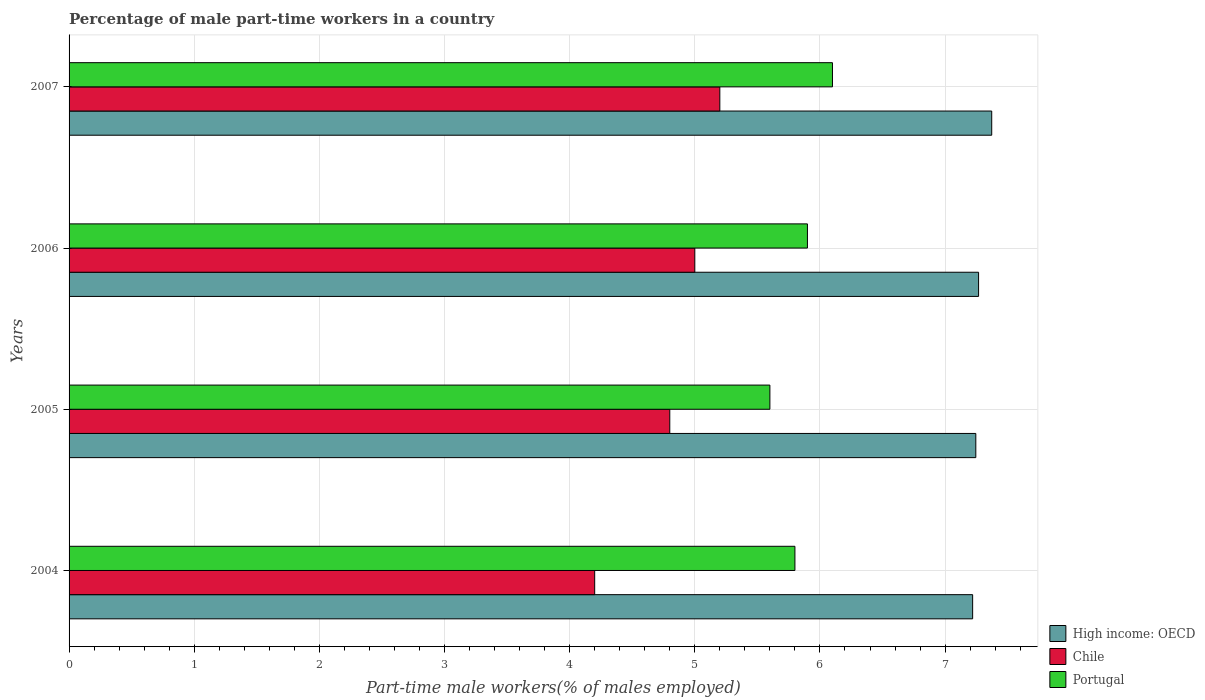How many groups of bars are there?
Provide a short and direct response. 4. How many bars are there on the 4th tick from the bottom?
Offer a very short reply. 3. What is the label of the 3rd group of bars from the top?
Offer a very short reply. 2005. In how many cases, is the number of bars for a given year not equal to the number of legend labels?
Your answer should be compact. 0. What is the percentage of male part-time workers in Portugal in 2006?
Keep it short and to the point. 5.9. Across all years, what is the maximum percentage of male part-time workers in High income: OECD?
Your answer should be compact. 7.37. Across all years, what is the minimum percentage of male part-time workers in Portugal?
Offer a terse response. 5.6. In which year was the percentage of male part-time workers in Chile minimum?
Keep it short and to the point. 2004. What is the total percentage of male part-time workers in Portugal in the graph?
Offer a very short reply. 23.4. What is the difference between the percentage of male part-time workers in High income: OECD in 2004 and that in 2006?
Give a very brief answer. -0.05. What is the difference between the percentage of male part-time workers in High income: OECD in 2004 and the percentage of male part-time workers in Chile in 2007?
Your answer should be very brief. 2.02. What is the average percentage of male part-time workers in High income: OECD per year?
Your response must be concise. 7.28. In the year 2004, what is the difference between the percentage of male part-time workers in High income: OECD and percentage of male part-time workers in Chile?
Make the answer very short. 3.02. What is the ratio of the percentage of male part-time workers in High income: OECD in 2004 to that in 2007?
Offer a very short reply. 0.98. Is the difference between the percentage of male part-time workers in High income: OECD in 2006 and 2007 greater than the difference between the percentage of male part-time workers in Chile in 2006 and 2007?
Your answer should be very brief. Yes. What is the difference between the highest and the second highest percentage of male part-time workers in Chile?
Provide a succinct answer. 0.2. In how many years, is the percentage of male part-time workers in High income: OECD greater than the average percentage of male part-time workers in High income: OECD taken over all years?
Make the answer very short. 1. What does the 3rd bar from the top in 2004 represents?
Your answer should be compact. High income: OECD. What does the 2nd bar from the bottom in 2006 represents?
Keep it short and to the point. Chile. How many years are there in the graph?
Ensure brevity in your answer.  4. What is the difference between two consecutive major ticks on the X-axis?
Your response must be concise. 1. Are the values on the major ticks of X-axis written in scientific E-notation?
Ensure brevity in your answer.  No. Does the graph contain grids?
Give a very brief answer. Yes. Where does the legend appear in the graph?
Make the answer very short. Bottom right. How are the legend labels stacked?
Your answer should be compact. Vertical. What is the title of the graph?
Make the answer very short. Percentage of male part-time workers in a country. Does "United Kingdom" appear as one of the legend labels in the graph?
Offer a very short reply. No. What is the label or title of the X-axis?
Provide a short and direct response. Part-time male workers(% of males employed). What is the label or title of the Y-axis?
Provide a succinct answer. Years. What is the Part-time male workers(% of males employed) of High income: OECD in 2004?
Provide a short and direct response. 7.22. What is the Part-time male workers(% of males employed) in Chile in 2004?
Your answer should be very brief. 4.2. What is the Part-time male workers(% of males employed) in Portugal in 2004?
Your response must be concise. 5.8. What is the Part-time male workers(% of males employed) in High income: OECD in 2005?
Ensure brevity in your answer.  7.25. What is the Part-time male workers(% of males employed) in Chile in 2005?
Ensure brevity in your answer.  4.8. What is the Part-time male workers(% of males employed) in Portugal in 2005?
Offer a terse response. 5.6. What is the Part-time male workers(% of males employed) in High income: OECD in 2006?
Your response must be concise. 7.27. What is the Part-time male workers(% of males employed) of Portugal in 2006?
Offer a very short reply. 5.9. What is the Part-time male workers(% of males employed) of High income: OECD in 2007?
Offer a very short reply. 7.37. What is the Part-time male workers(% of males employed) in Chile in 2007?
Give a very brief answer. 5.2. What is the Part-time male workers(% of males employed) of Portugal in 2007?
Give a very brief answer. 6.1. Across all years, what is the maximum Part-time male workers(% of males employed) of High income: OECD?
Your response must be concise. 7.37. Across all years, what is the maximum Part-time male workers(% of males employed) of Chile?
Provide a short and direct response. 5.2. Across all years, what is the maximum Part-time male workers(% of males employed) of Portugal?
Keep it short and to the point. 6.1. Across all years, what is the minimum Part-time male workers(% of males employed) of High income: OECD?
Offer a terse response. 7.22. Across all years, what is the minimum Part-time male workers(% of males employed) of Chile?
Your answer should be compact. 4.2. Across all years, what is the minimum Part-time male workers(% of males employed) of Portugal?
Offer a terse response. 5.6. What is the total Part-time male workers(% of males employed) of High income: OECD in the graph?
Offer a very short reply. 29.11. What is the total Part-time male workers(% of males employed) in Chile in the graph?
Your answer should be compact. 19.2. What is the total Part-time male workers(% of males employed) in Portugal in the graph?
Provide a succinct answer. 23.4. What is the difference between the Part-time male workers(% of males employed) of High income: OECD in 2004 and that in 2005?
Give a very brief answer. -0.03. What is the difference between the Part-time male workers(% of males employed) of Portugal in 2004 and that in 2005?
Your response must be concise. 0.2. What is the difference between the Part-time male workers(% of males employed) in High income: OECD in 2004 and that in 2006?
Offer a very short reply. -0.05. What is the difference between the Part-time male workers(% of males employed) of Portugal in 2004 and that in 2006?
Your response must be concise. -0.1. What is the difference between the Part-time male workers(% of males employed) in High income: OECD in 2004 and that in 2007?
Your answer should be very brief. -0.15. What is the difference between the Part-time male workers(% of males employed) in High income: OECD in 2005 and that in 2006?
Your answer should be very brief. -0.02. What is the difference between the Part-time male workers(% of males employed) of Portugal in 2005 and that in 2006?
Ensure brevity in your answer.  -0.3. What is the difference between the Part-time male workers(% of males employed) in High income: OECD in 2005 and that in 2007?
Make the answer very short. -0.13. What is the difference between the Part-time male workers(% of males employed) of Chile in 2005 and that in 2007?
Your answer should be compact. -0.4. What is the difference between the Part-time male workers(% of males employed) of Portugal in 2005 and that in 2007?
Your response must be concise. -0.5. What is the difference between the Part-time male workers(% of males employed) in High income: OECD in 2006 and that in 2007?
Your response must be concise. -0.1. What is the difference between the Part-time male workers(% of males employed) of Portugal in 2006 and that in 2007?
Give a very brief answer. -0.2. What is the difference between the Part-time male workers(% of males employed) in High income: OECD in 2004 and the Part-time male workers(% of males employed) in Chile in 2005?
Provide a succinct answer. 2.42. What is the difference between the Part-time male workers(% of males employed) in High income: OECD in 2004 and the Part-time male workers(% of males employed) in Portugal in 2005?
Keep it short and to the point. 1.62. What is the difference between the Part-time male workers(% of males employed) of Chile in 2004 and the Part-time male workers(% of males employed) of Portugal in 2005?
Provide a succinct answer. -1.4. What is the difference between the Part-time male workers(% of males employed) of High income: OECD in 2004 and the Part-time male workers(% of males employed) of Chile in 2006?
Provide a short and direct response. 2.22. What is the difference between the Part-time male workers(% of males employed) in High income: OECD in 2004 and the Part-time male workers(% of males employed) in Portugal in 2006?
Give a very brief answer. 1.32. What is the difference between the Part-time male workers(% of males employed) of Chile in 2004 and the Part-time male workers(% of males employed) of Portugal in 2006?
Make the answer very short. -1.7. What is the difference between the Part-time male workers(% of males employed) of High income: OECD in 2004 and the Part-time male workers(% of males employed) of Chile in 2007?
Ensure brevity in your answer.  2.02. What is the difference between the Part-time male workers(% of males employed) in High income: OECD in 2004 and the Part-time male workers(% of males employed) in Portugal in 2007?
Your answer should be very brief. 1.12. What is the difference between the Part-time male workers(% of males employed) of Chile in 2004 and the Part-time male workers(% of males employed) of Portugal in 2007?
Your response must be concise. -1.9. What is the difference between the Part-time male workers(% of males employed) in High income: OECD in 2005 and the Part-time male workers(% of males employed) in Chile in 2006?
Ensure brevity in your answer.  2.25. What is the difference between the Part-time male workers(% of males employed) of High income: OECD in 2005 and the Part-time male workers(% of males employed) of Portugal in 2006?
Ensure brevity in your answer.  1.35. What is the difference between the Part-time male workers(% of males employed) in High income: OECD in 2005 and the Part-time male workers(% of males employed) in Chile in 2007?
Offer a very short reply. 2.05. What is the difference between the Part-time male workers(% of males employed) of High income: OECD in 2005 and the Part-time male workers(% of males employed) of Portugal in 2007?
Keep it short and to the point. 1.15. What is the difference between the Part-time male workers(% of males employed) of High income: OECD in 2006 and the Part-time male workers(% of males employed) of Chile in 2007?
Your response must be concise. 2.07. What is the difference between the Part-time male workers(% of males employed) of High income: OECD in 2006 and the Part-time male workers(% of males employed) of Portugal in 2007?
Your response must be concise. 1.17. What is the difference between the Part-time male workers(% of males employed) in Chile in 2006 and the Part-time male workers(% of males employed) in Portugal in 2007?
Offer a very short reply. -1.1. What is the average Part-time male workers(% of males employed) of High income: OECD per year?
Ensure brevity in your answer.  7.28. What is the average Part-time male workers(% of males employed) in Chile per year?
Your response must be concise. 4.8. What is the average Part-time male workers(% of males employed) in Portugal per year?
Provide a short and direct response. 5.85. In the year 2004, what is the difference between the Part-time male workers(% of males employed) of High income: OECD and Part-time male workers(% of males employed) of Chile?
Give a very brief answer. 3.02. In the year 2004, what is the difference between the Part-time male workers(% of males employed) in High income: OECD and Part-time male workers(% of males employed) in Portugal?
Provide a short and direct response. 1.42. In the year 2004, what is the difference between the Part-time male workers(% of males employed) in Chile and Part-time male workers(% of males employed) in Portugal?
Your response must be concise. -1.6. In the year 2005, what is the difference between the Part-time male workers(% of males employed) of High income: OECD and Part-time male workers(% of males employed) of Chile?
Provide a short and direct response. 2.45. In the year 2005, what is the difference between the Part-time male workers(% of males employed) of High income: OECD and Part-time male workers(% of males employed) of Portugal?
Make the answer very short. 1.65. In the year 2005, what is the difference between the Part-time male workers(% of males employed) in Chile and Part-time male workers(% of males employed) in Portugal?
Give a very brief answer. -0.8. In the year 2006, what is the difference between the Part-time male workers(% of males employed) of High income: OECD and Part-time male workers(% of males employed) of Chile?
Keep it short and to the point. 2.27. In the year 2006, what is the difference between the Part-time male workers(% of males employed) in High income: OECD and Part-time male workers(% of males employed) in Portugal?
Make the answer very short. 1.37. In the year 2007, what is the difference between the Part-time male workers(% of males employed) in High income: OECD and Part-time male workers(% of males employed) in Chile?
Offer a terse response. 2.17. In the year 2007, what is the difference between the Part-time male workers(% of males employed) in High income: OECD and Part-time male workers(% of males employed) in Portugal?
Make the answer very short. 1.27. In the year 2007, what is the difference between the Part-time male workers(% of males employed) in Chile and Part-time male workers(% of males employed) in Portugal?
Give a very brief answer. -0.9. What is the ratio of the Part-time male workers(% of males employed) in High income: OECD in 2004 to that in 2005?
Make the answer very short. 1. What is the ratio of the Part-time male workers(% of males employed) of Portugal in 2004 to that in 2005?
Make the answer very short. 1.04. What is the ratio of the Part-time male workers(% of males employed) of High income: OECD in 2004 to that in 2006?
Provide a short and direct response. 0.99. What is the ratio of the Part-time male workers(% of males employed) in Chile in 2004 to that in 2006?
Ensure brevity in your answer.  0.84. What is the ratio of the Part-time male workers(% of males employed) in Portugal in 2004 to that in 2006?
Offer a very short reply. 0.98. What is the ratio of the Part-time male workers(% of males employed) in High income: OECD in 2004 to that in 2007?
Provide a short and direct response. 0.98. What is the ratio of the Part-time male workers(% of males employed) of Chile in 2004 to that in 2007?
Provide a short and direct response. 0.81. What is the ratio of the Part-time male workers(% of males employed) of Portugal in 2004 to that in 2007?
Offer a very short reply. 0.95. What is the ratio of the Part-time male workers(% of males employed) in High income: OECD in 2005 to that in 2006?
Your answer should be compact. 1. What is the ratio of the Part-time male workers(% of males employed) of Chile in 2005 to that in 2006?
Your answer should be compact. 0.96. What is the ratio of the Part-time male workers(% of males employed) in Portugal in 2005 to that in 2006?
Your response must be concise. 0.95. What is the ratio of the Part-time male workers(% of males employed) in High income: OECD in 2005 to that in 2007?
Your answer should be very brief. 0.98. What is the ratio of the Part-time male workers(% of males employed) in Portugal in 2005 to that in 2007?
Your answer should be very brief. 0.92. What is the ratio of the Part-time male workers(% of males employed) of High income: OECD in 2006 to that in 2007?
Keep it short and to the point. 0.99. What is the ratio of the Part-time male workers(% of males employed) in Chile in 2006 to that in 2007?
Make the answer very short. 0.96. What is the ratio of the Part-time male workers(% of males employed) of Portugal in 2006 to that in 2007?
Your answer should be very brief. 0.97. What is the difference between the highest and the second highest Part-time male workers(% of males employed) in High income: OECD?
Provide a succinct answer. 0.1. What is the difference between the highest and the second highest Part-time male workers(% of males employed) in Chile?
Keep it short and to the point. 0.2. What is the difference between the highest and the lowest Part-time male workers(% of males employed) in High income: OECD?
Your answer should be compact. 0.15. 